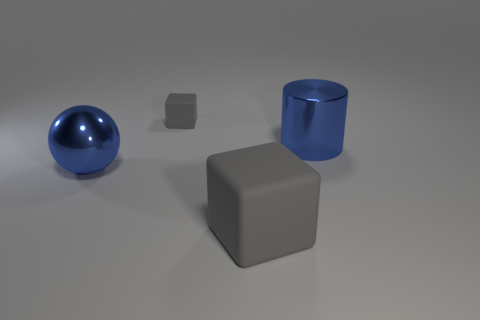Is the shape of the small gray rubber thing the same as the large gray thing?
Provide a short and direct response. Yes. There is a object that is right of the small rubber block and left of the cylinder; what is it made of?
Offer a terse response. Rubber. What number of other metallic things have the same shape as the small gray object?
Offer a terse response. 0. How big is the matte block in front of the cube behind the large blue cylinder in front of the tiny gray rubber thing?
Give a very brief answer. Large. Is the number of big gray rubber things that are right of the large matte block greater than the number of small blue shiny spheres?
Your answer should be very brief. No. Are any small things visible?
Provide a succinct answer. Yes. What number of blue metal spheres are the same size as the cylinder?
Keep it short and to the point. 1. Is the number of big things behind the large cylinder greater than the number of gray matte blocks on the left side of the big gray rubber block?
Your answer should be very brief. No. There is a blue thing that is the same size as the blue cylinder; what is its material?
Your response must be concise. Metal. What shape is the tiny object?
Your response must be concise. Cube. 